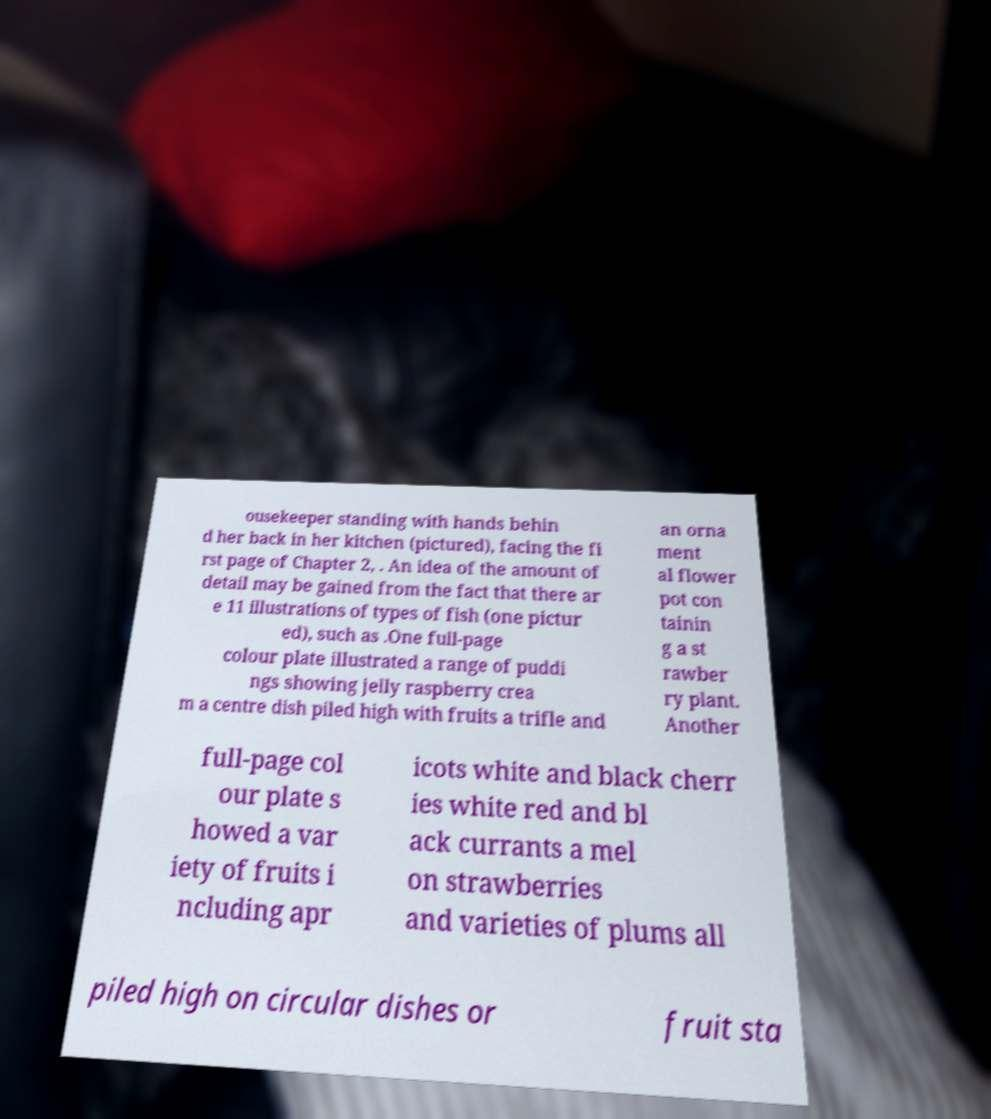Please identify and transcribe the text found in this image. ousekeeper standing with hands behin d her back in her kitchen (pictured), facing the fi rst page of Chapter 2, . An idea of the amount of detail may be gained from the fact that there ar e 11 illustrations of types of fish (one pictur ed), such as .One full-page colour plate illustrated a range of puddi ngs showing jelly raspberry crea m a centre dish piled high with fruits a trifle and an orna ment al flower pot con tainin g a st rawber ry plant. Another full-page col our plate s howed a var iety of fruits i ncluding apr icots white and black cherr ies white red and bl ack currants a mel on strawberries and varieties of plums all piled high on circular dishes or fruit sta 